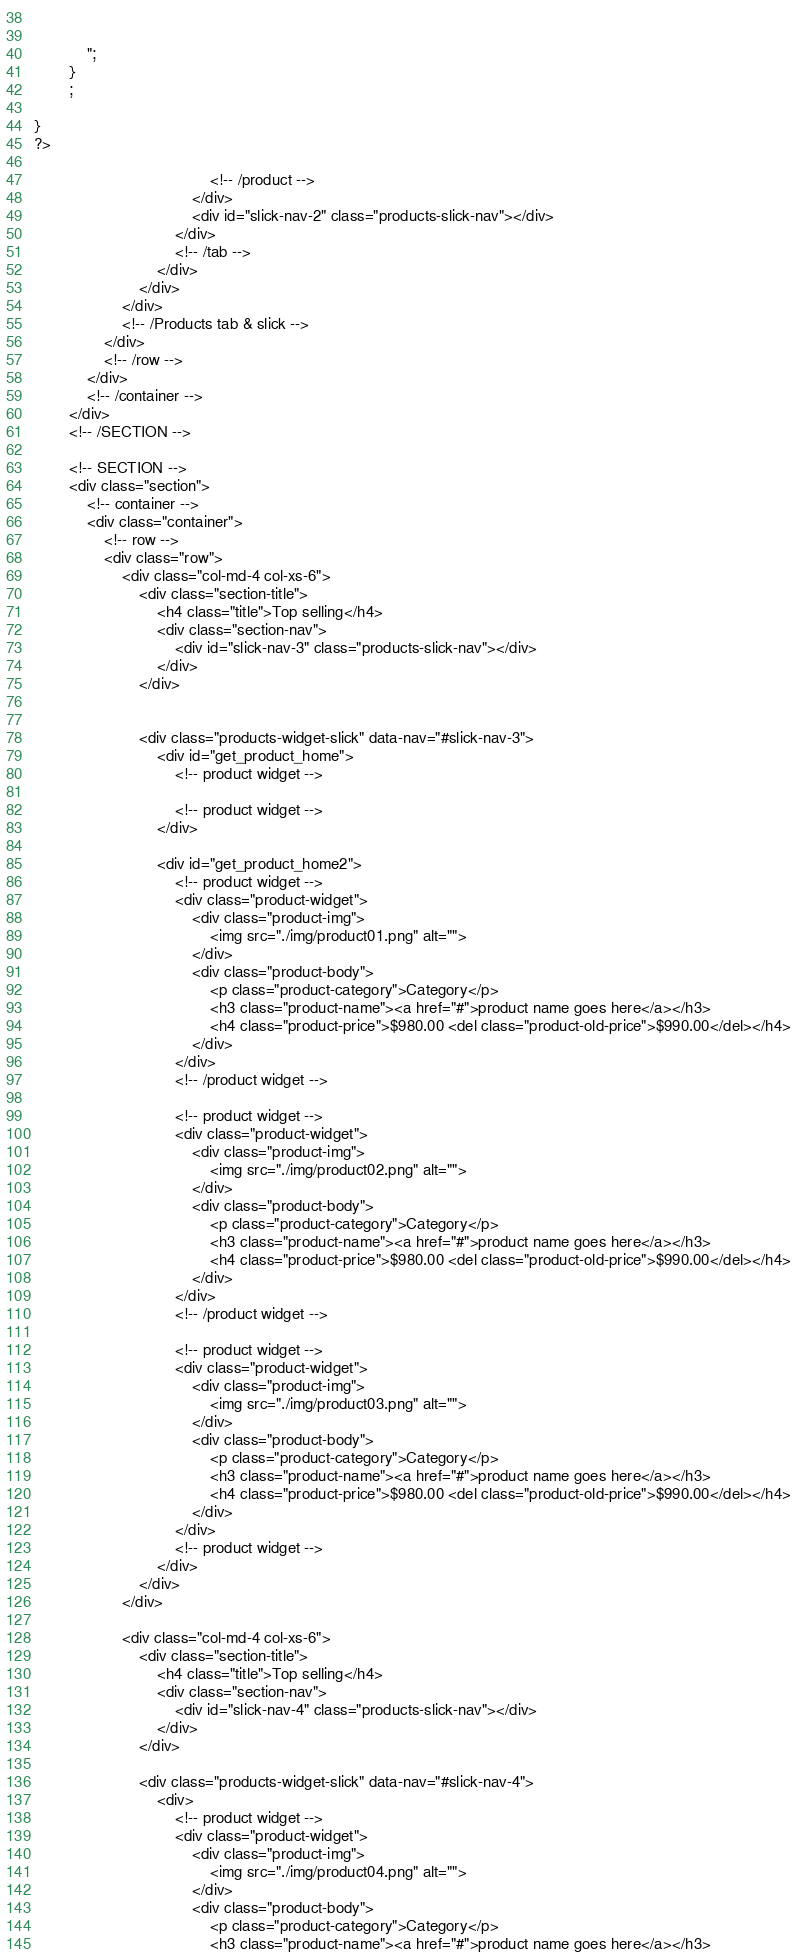Convert code to text. <code><loc_0><loc_0><loc_500><loc_500><_PHP_>							
                        
			";
		}
        ;
      
}
?>
										
										<!-- /product -->
									</div>
									<div id="slick-nav-2" class="products-slick-nav"></div>
								</div>
								<!-- /tab -->
							</div>
						</div>
					</div>
					<!-- /Products tab & slick -->
				</div>
				<!-- /row -->
			</div>
			<!-- /container -->
		</div>
		<!-- /SECTION -->

		<!-- SECTION -->
		<div class="section">
			<!-- container -->
			<div class="container">
				<!-- row -->
				<div class="row">
					<div class="col-md-4 col-xs-6">
						<div class="section-title">
							<h4 class="title">Top selling</h4>
							<div class="section-nav">
								<div id="slick-nav-3" class="products-slick-nav"></div>
							</div>
						</div>
						

						<div class="products-widget-slick" data-nav="#slick-nav-3">
							<div id="get_product_home">
								<!-- product widget -->
								
								<!-- product widget -->
							</div>

							<div id="get_product_home2">
								<!-- product widget -->
								<div class="product-widget">
									<div class="product-img">
										<img src="./img/product01.png" alt="">
									</div>
									<div class="product-body">
										<p class="product-category">Category</p>
										<h3 class="product-name"><a href="#">product name goes here</a></h3>
										<h4 class="product-price">$980.00 <del class="product-old-price">$990.00</del></h4>
									</div>
								</div>
								<!-- /product widget -->

								<!-- product widget -->
								<div class="product-widget">
									<div class="product-img">
										<img src="./img/product02.png" alt="">
									</div>
									<div class="product-body">
										<p class="product-category">Category</p>
										<h3 class="product-name"><a href="#">product name goes here</a></h3>
										<h4 class="product-price">$980.00 <del class="product-old-price">$990.00</del></h4>
									</div>
								</div>
								<!-- /product widget -->

								<!-- product widget -->
								<div class="product-widget">
									<div class="product-img">
										<img src="./img/product03.png" alt="">
									</div>
									<div class="product-body">
										<p class="product-category">Category</p>
										<h3 class="product-name"><a href="#">product name goes here</a></h3>
										<h4 class="product-price">$980.00 <del class="product-old-price">$990.00</del></h4>
									</div>
								</div>
								<!-- product widget -->
							</div>
						</div>
					</div>

					<div class="col-md-4 col-xs-6">
						<div class="section-title">
							<h4 class="title">Top selling</h4>
							<div class="section-nav">
								<div id="slick-nav-4" class="products-slick-nav"></div>
							</div>
						</div>

						<div class="products-widget-slick" data-nav="#slick-nav-4">
							<div>
								<!-- product widget -->
								<div class="product-widget">
									<div class="product-img">
										<img src="./img/product04.png" alt="">
									</div>
									<div class="product-body">
										<p class="product-category">Category</p>
										<h3 class="product-name"><a href="#">product name goes here</a></h3></code> 